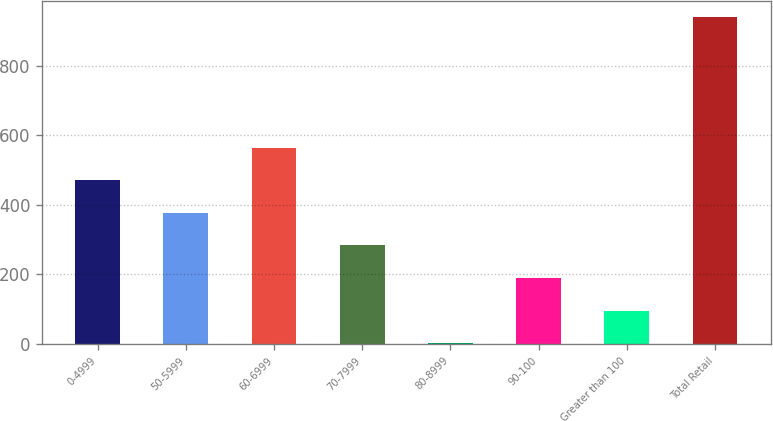Convert chart to OTSL. <chart><loc_0><loc_0><loc_500><loc_500><bar_chart><fcel>0-4999<fcel>50-5999<fcel>60-6999<fcel>70-7999<fcel>80-8999<fcel>90-100<fcel>Greater than 100<fcel>Total Retail<nl><fcel>470.76<fcel>376.91<fcel>564.61<fcel>283.06<fcel>1.51<fcel>189.21<fcel>95.36<fcel>940<nl></chart> 